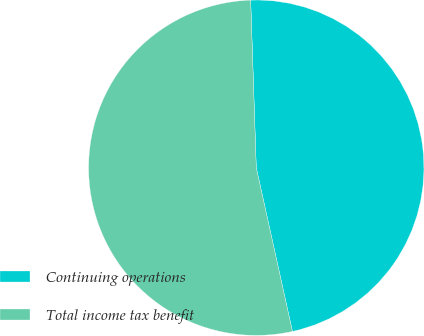<chart> <loc_0><loc_0><loc_500><loc_500><pie_chart><fcel>Continuing operations<fcel>Total income tax benefit<nl><fcel>47.07%<fcel>52.93%<nl></chart> 